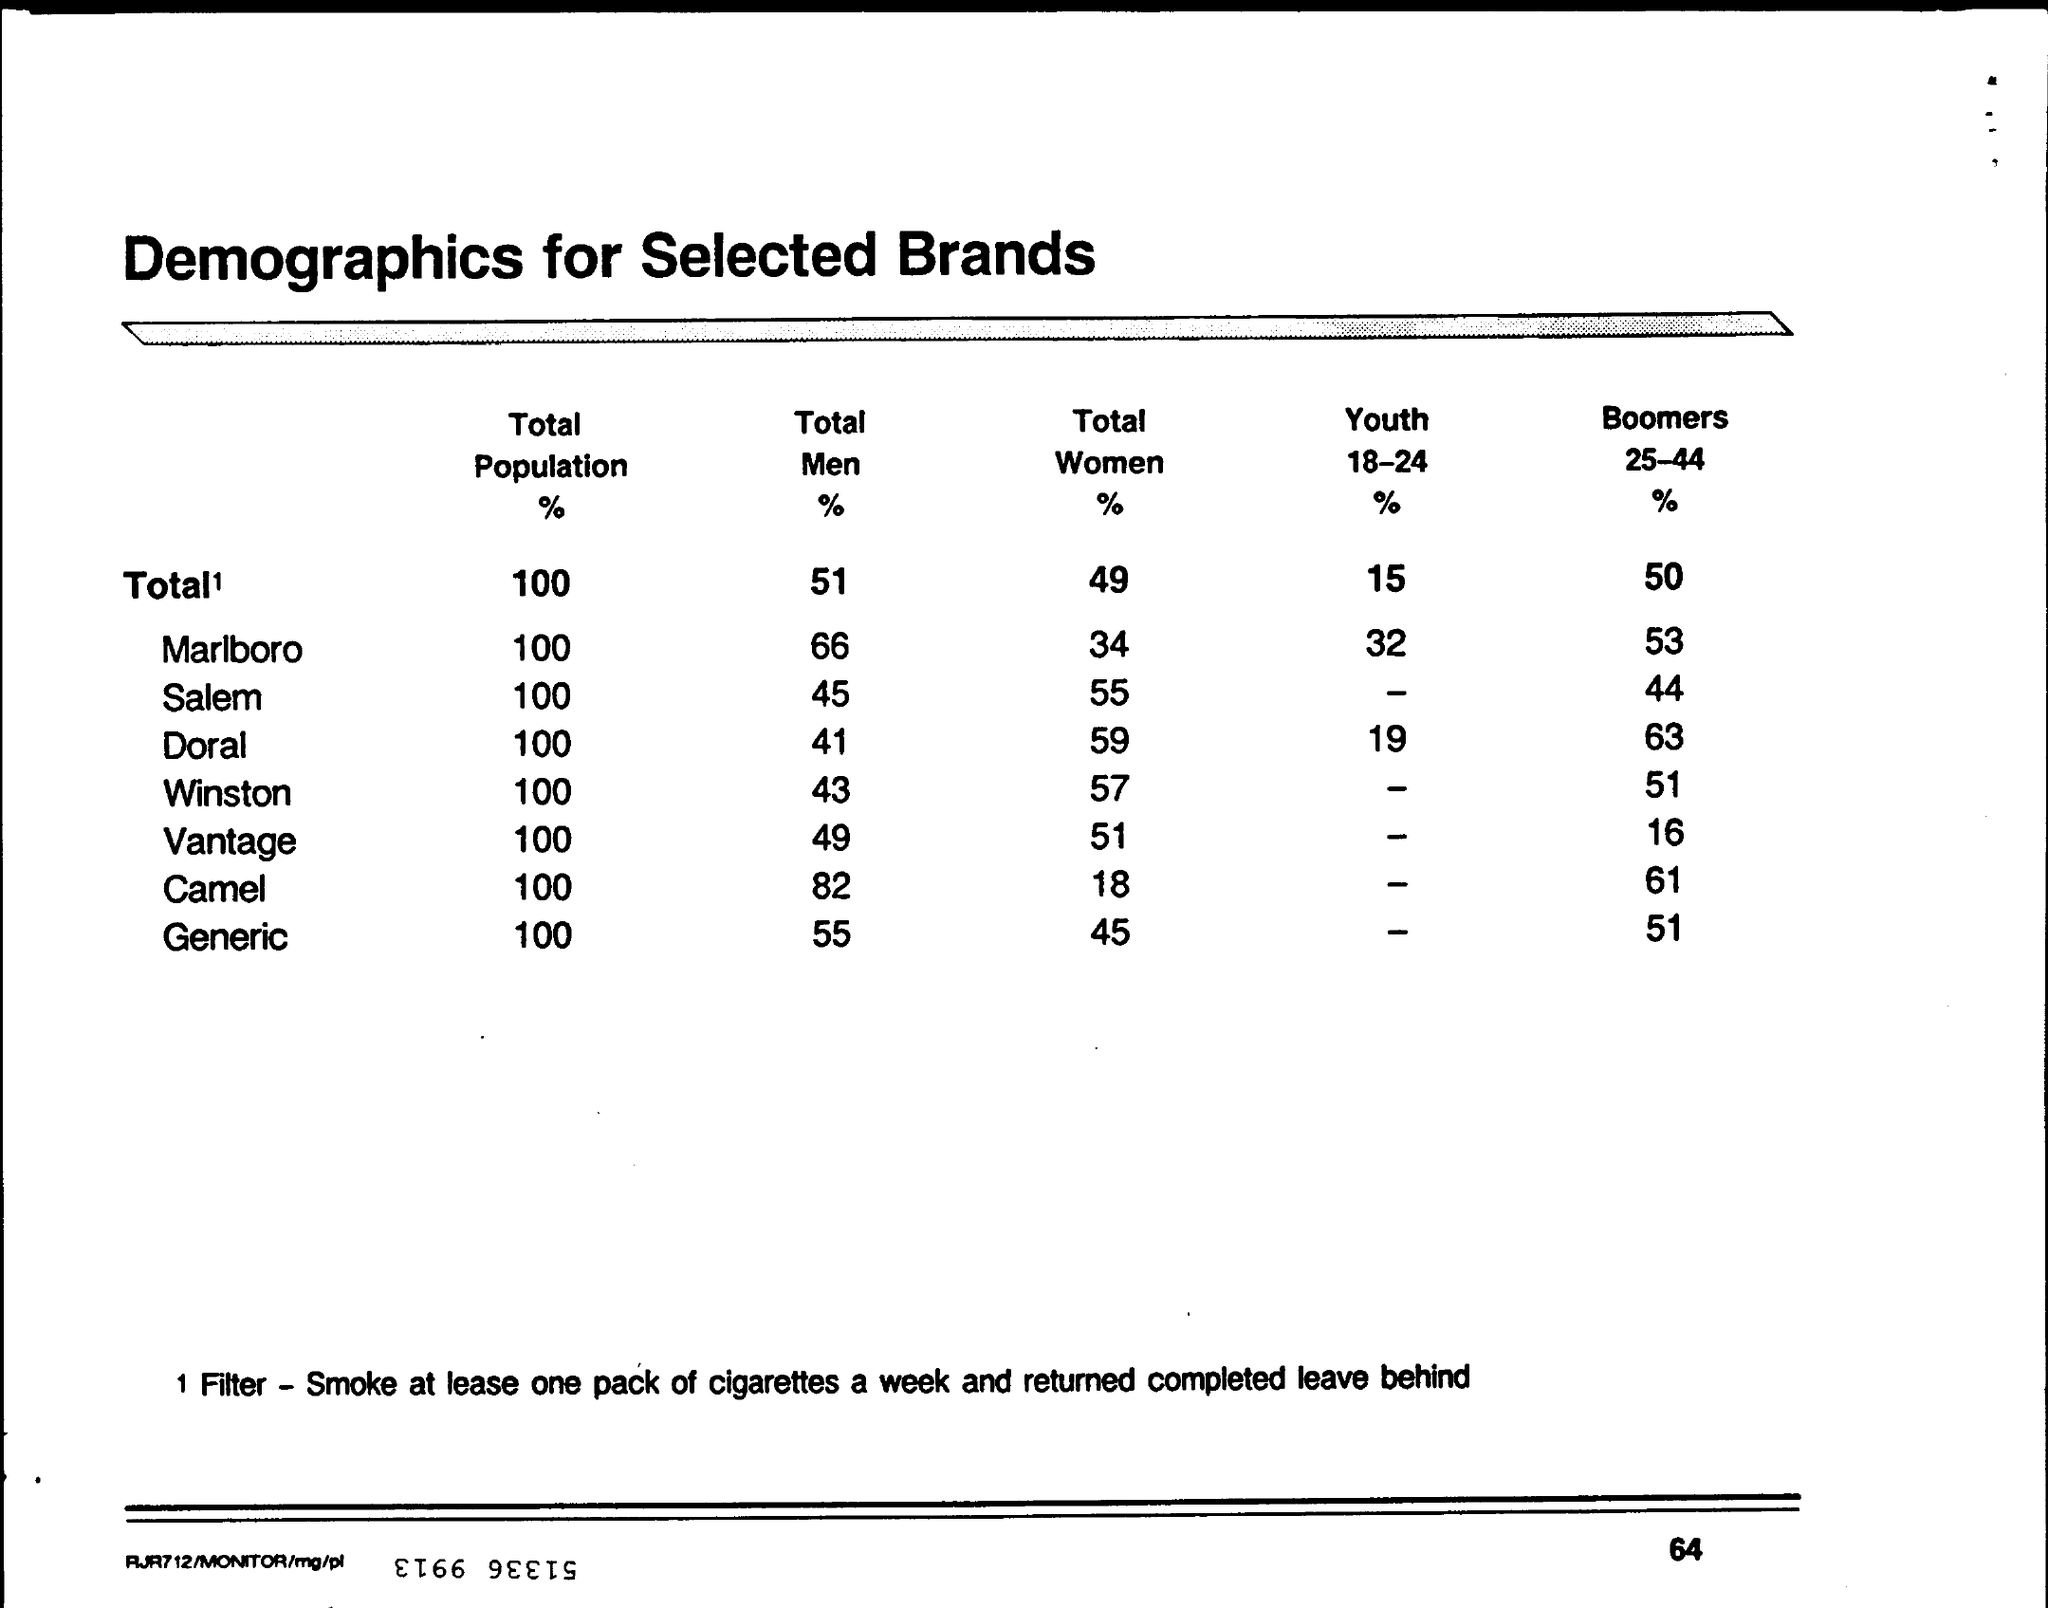What is the Total Men % for Marlboro?
Offer a very short reply. 66. What is the Total Men % for Winston?
Give a very brief answer. 43. What is the Total Men % for Salem?
Give a very brief answer. 45. What is the Total Men % for Doral?
Keep it short and to the point. 41. What is the Total Women % for Marlboro?
Keep it short and to the point. 34. What is the Total Women % for Camel?
Provide a succinct answer. 18. What is the Total Women % for Doral?
Make the answer very short. 59. What is the Total Women % for Vantage?
Keep it short and to the point. 51. What is the Heading of the Table?
Your answer should be compact. Demographics for selected brands. What is the Total Women % for Winston?
Ensure brevity in your answer.  57. 